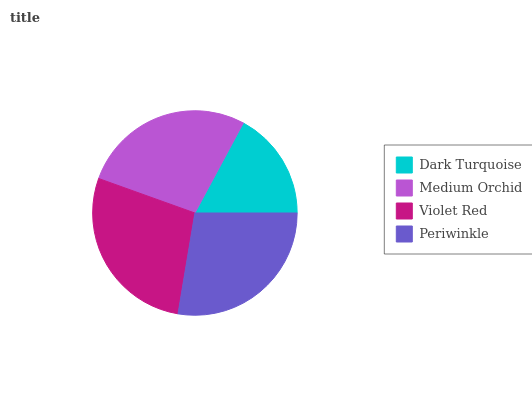Is Dark Turquoise the minimum?
Answer yes or no. Yes. Is Violet Red the maximum?
Answer yes or no. Yes. Is Medium Orchid the minimum?
Answer yes or no. No. Is Medium Orchid the maximum?
Answer yes or no. No. Is Medium Orchid greater than Dark Turquoise?
Answer yes or no. Yes. Is Dark Turquoise less than Medium Orchid?
Answer yes or no. Yes. Is Dark Turquoise greater than Medium Orchid?
Answer yes or no. No. Is Medium Orchid less than Dark Turquoise?
Answer yes or no. No. Is Periwinkle the high median?
Answer yes or no. Yes. Is Medium Orchid the low median?
Answer yes or no. Yes. Is Medium Orchid the high median?
Answer yes or no. No. Is Violet Red the low median?
Answer yes or no. No. 